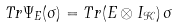<formula> <loc_0><loc_0><loc_500><loc_500>T r \Psi _ { E } ( \sigma ) = T r ( E \otimes I _ { \mathcal { K } } ) \, \sigma</formula> 